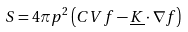Convert formula to latex. <formula><loc_0><loc_0><loc_500><loc_500>S = 4 \pi p ^ { 2 } \left ( C V f - \underline { K } \cdot \nabla f \right )</formula> 